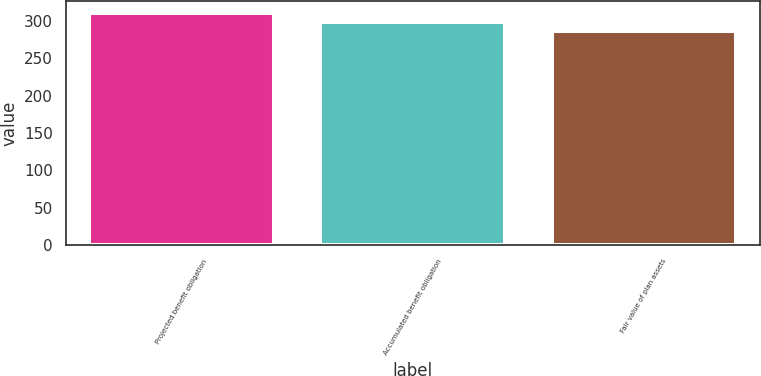Convert chart. <chart><loc_0><loc_0><loc_500><loc_500><bar_chart><fcel>Projected benefit obligation<fcel>Accumulated benefit obligation<fcel>Fair value of plan assets<nl><fcel>311<fcel>299<fcel>286<nl></chart> 